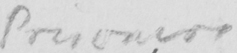Transcribe the text shown in this historical manuscript line. Prisoners 